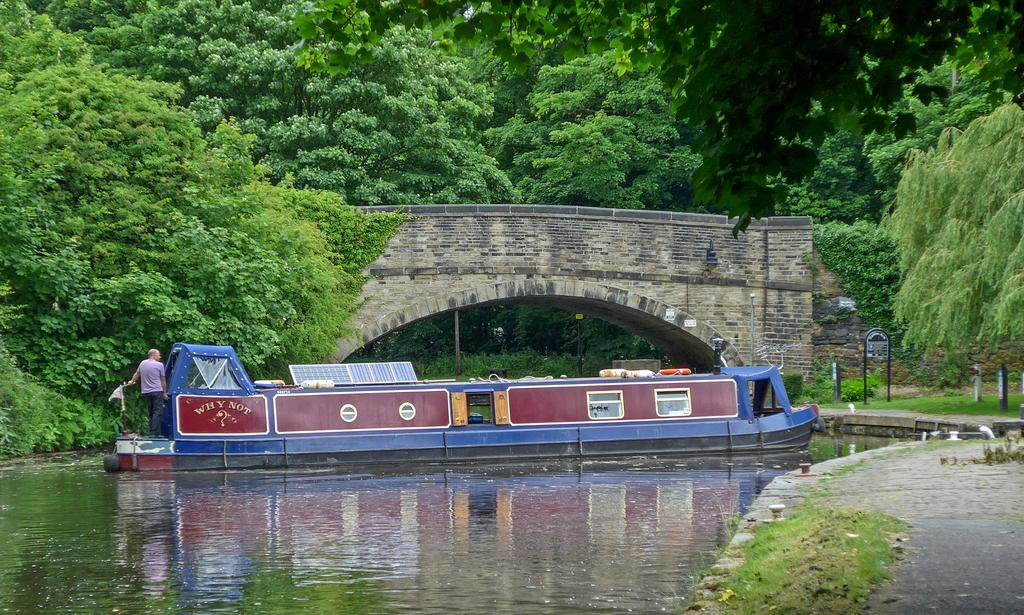What is in the water in the image? There is a boat in the water in the image. Who is on the boat? A man is standing on the boat. What is located near the boat? There is a sign board beside the boat. What can be seen in the background of the image? Trees are visible in the image. What architectural feature is present over the water? There is a bridge over the water. What type of calendar is hanging on the bridge in the image? There is no calendar present in the image; it features a boat, a man, a sign board, trees, and a bridge over the water. 